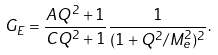<formula> <loc_0><loc_0><loc_500><loc_500>G _ { E } = \frac { A Q ^ { 2 } + 1 } { C Q ^ { 2 } + 1 } \frac { 1 } { ( 1 + Q ^ { 2 } / M _ { e } ^ { 2 } ) ^ { 2 } } .</formula> 